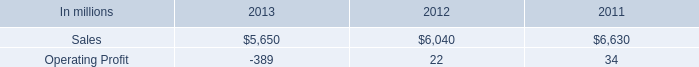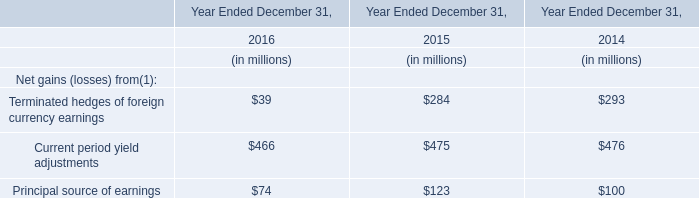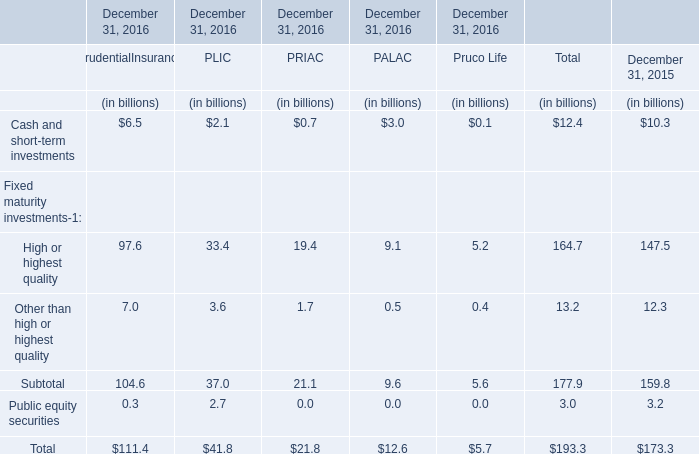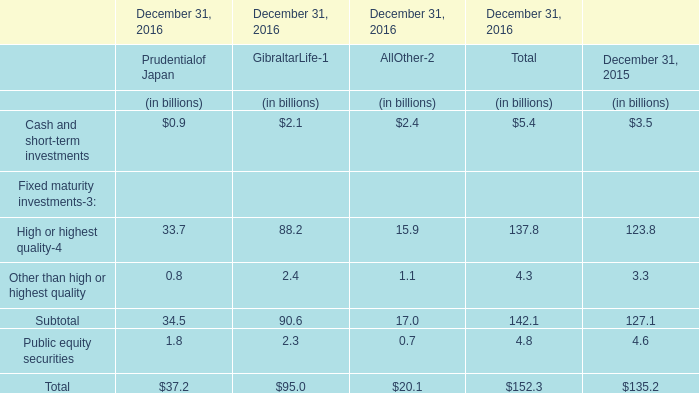What is the percentage of all Other than high or highest quality that are positive to the total amount, in 2016? 
Computations: (((0.8 + 2.4) + 1.1) / 4.3)
Answer: 1.0. 